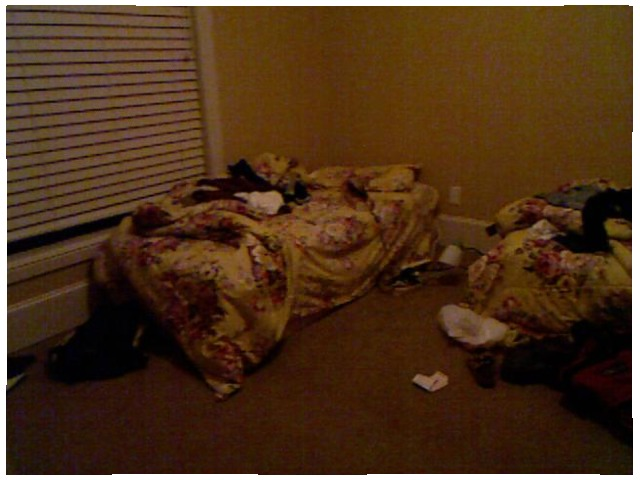<image>
Can you confirm if the shoe is in front of the bed? No. The shoe is not in front of the bed. The spatial positioning shows a different relationship between these objects. Is the shoe next to the bed? Yes. The shoe is positioned adjacent to the bed, located nearby in the same general area. 